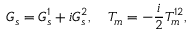<formula> <loc_0><loc_0><loc_500><loc_500>G _ { s } = G _ { s } ^ { 1 } + i G _ { s } ^ { 2 } , \quad T _ { m } = - \frac { i } { 2 } T _ { m } ^ { 1 2 } ,</formula> 